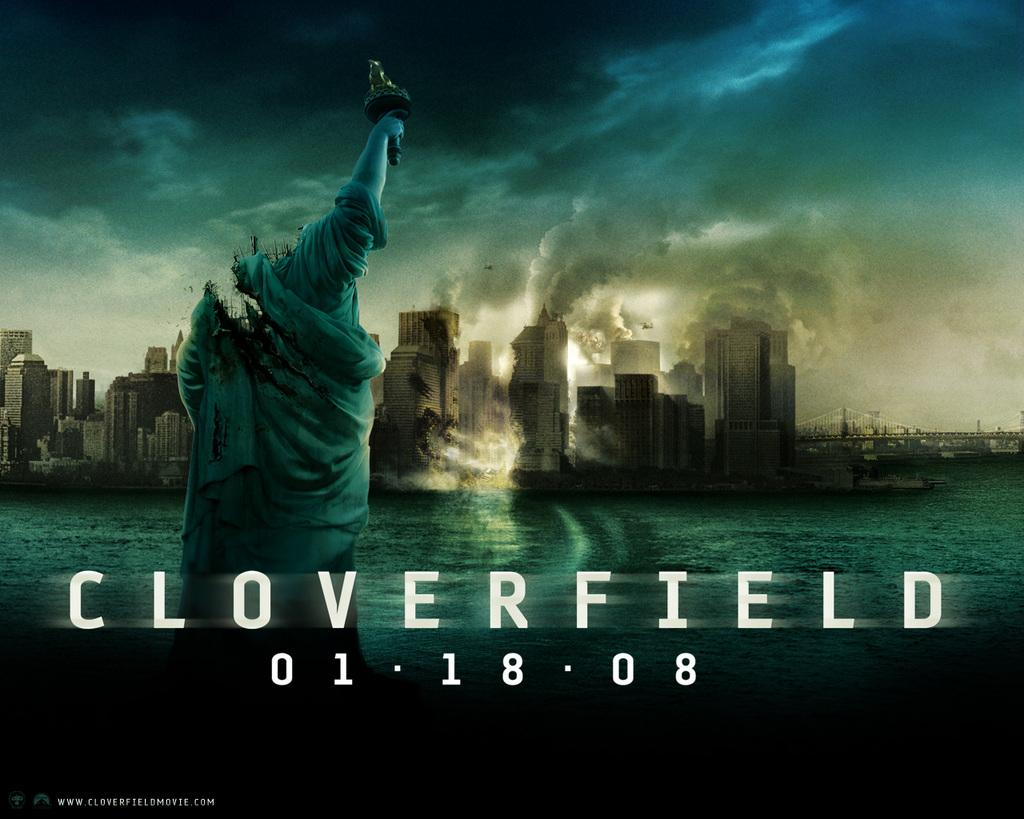<image>
Render a clear and concise summary of the photo. A cover photo of the movie of Cloverfield the file for 01/18/08. 